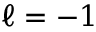Convert formula to latex. <formula><loc_0><loc_0><loc_500><loc_500>\ell = - 1</formula> 